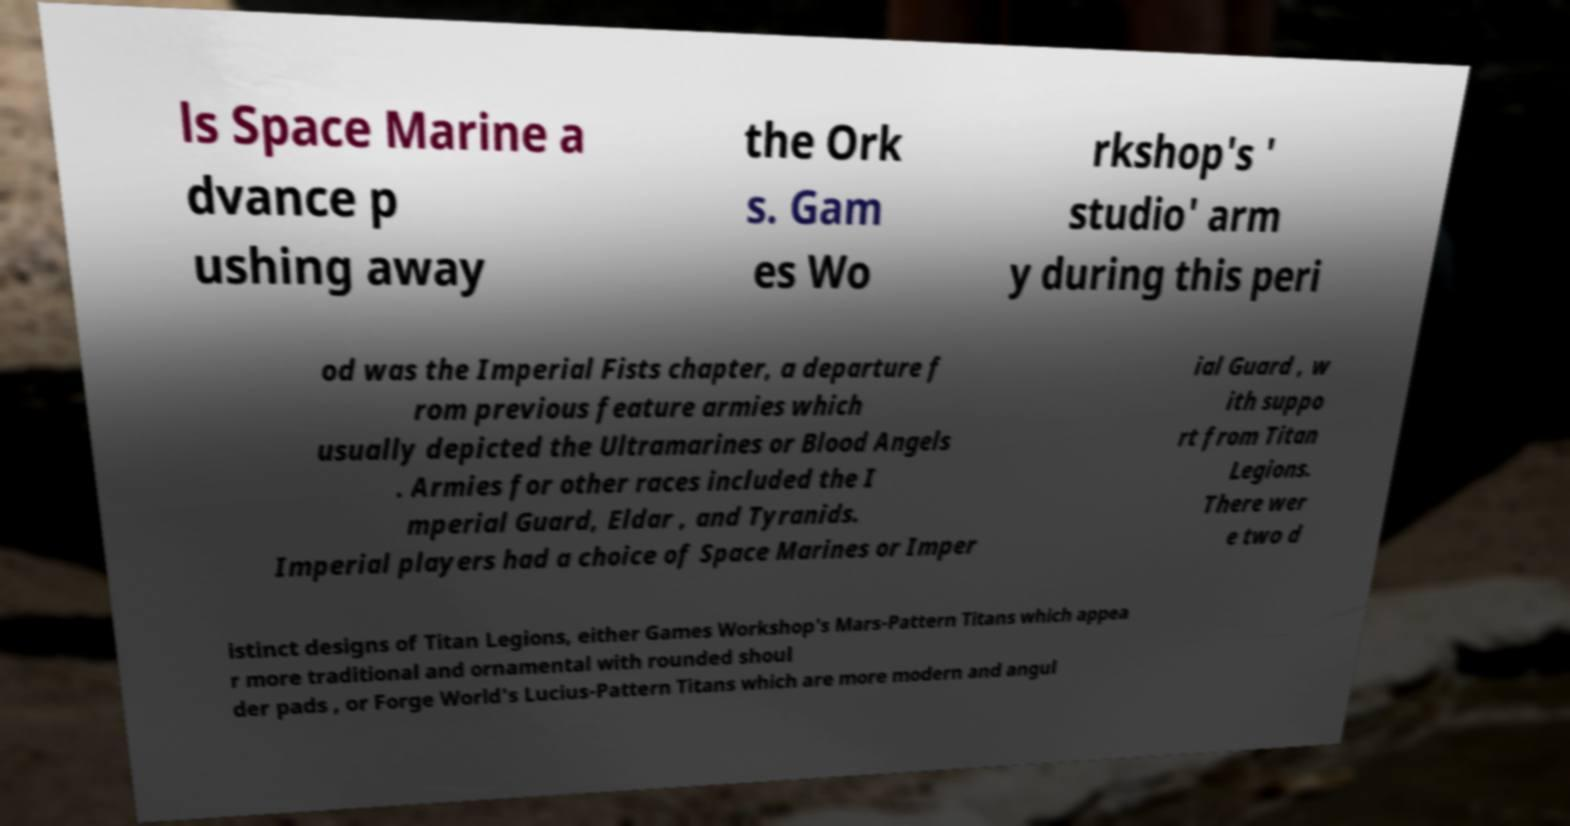Could you extract and type out the text from this image? ls Space Marine a dvance p ushing away the Ork s. Gam es Wo rkshop's ' studio' arm y during this peri od was the Imperial Fists chapter, a departure f rom previous feature armies which usually depicted the Ultramarines or Blood Angels . Armies for other races included the I mperial Guard, Eldar , and Tyranids. Imperial players had a choice of Space Marines or Imper ial Guard , w ith suppo rt from Titan Legions. There wer e two d istinct designs of Titan Legions, either Games Workshop's Mars-Pattern Titans which appea r more traditional and ornamental with rounded shoul der pads , or Forge World's Lucius-Pattern Titans which are more modern and angul 